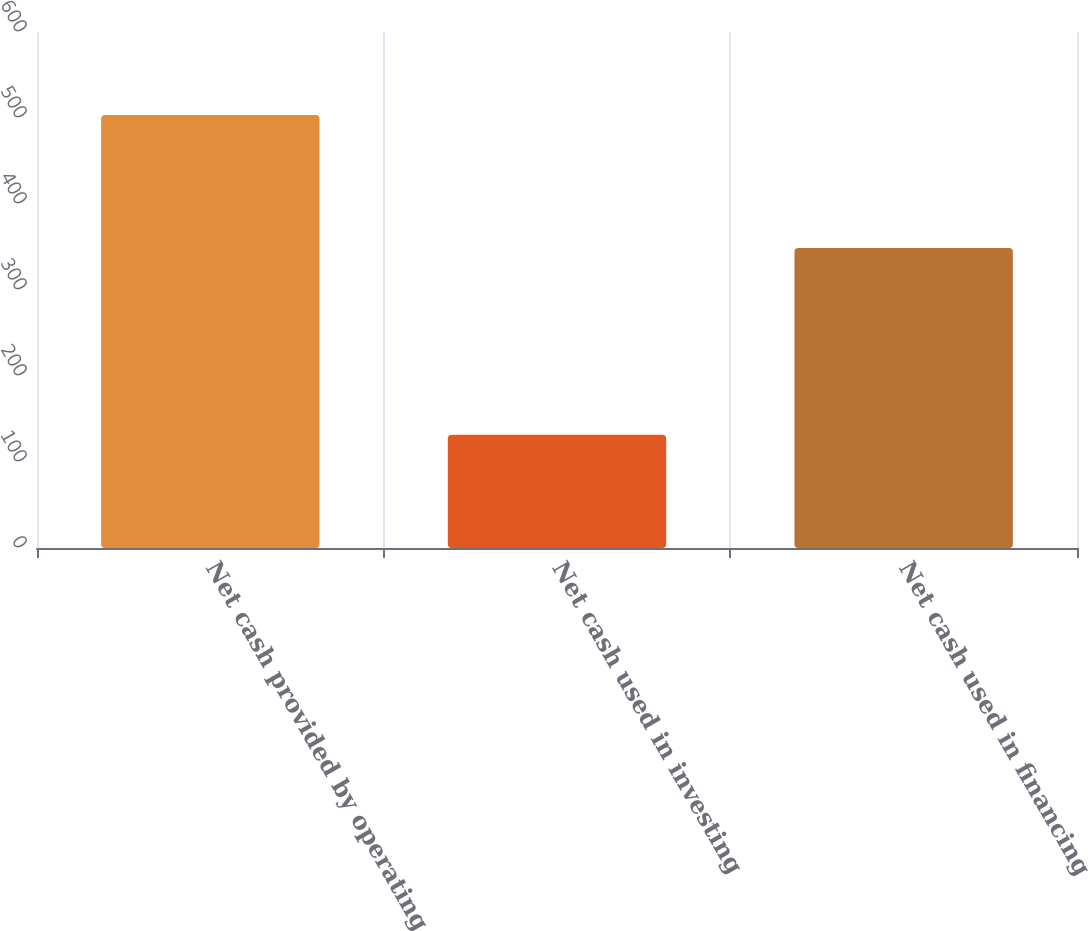Convert chart. <chart><loc_0><loc_0><loc_500><loc_500><bar_chart><fcel>Net cash provided by operating<fcel>Net cash used in investing<fcel>Net cash used in financing<nl><fcel>503.6<fcel>131.6<fcel>348.9<nl></chart> 